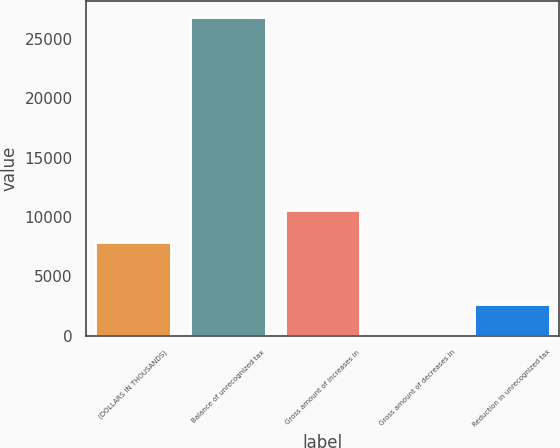<chart> <loc_0><loc_0><loc_500><loc_500><bar_chart><fcel>(DOLLARS IN THOUSANDS)<fcel>Balance of unrecognized tax<fcel>Gross amount of increases in<fcel>Gross amount of decreases in<fcel>Reduction in unrecognized tax<nl><fcel>7930.5<fcel>26840.5<fcel>10573<fcel>3<fcel>2645.5<nl></chart> 